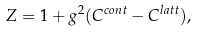<formula> <loc_0><loc_0><loc_500><loc_500>Z = 1 + g ^ { 2 } ( C ^ { c o n t } - C ^ { l a t t } ) ,</formula> 